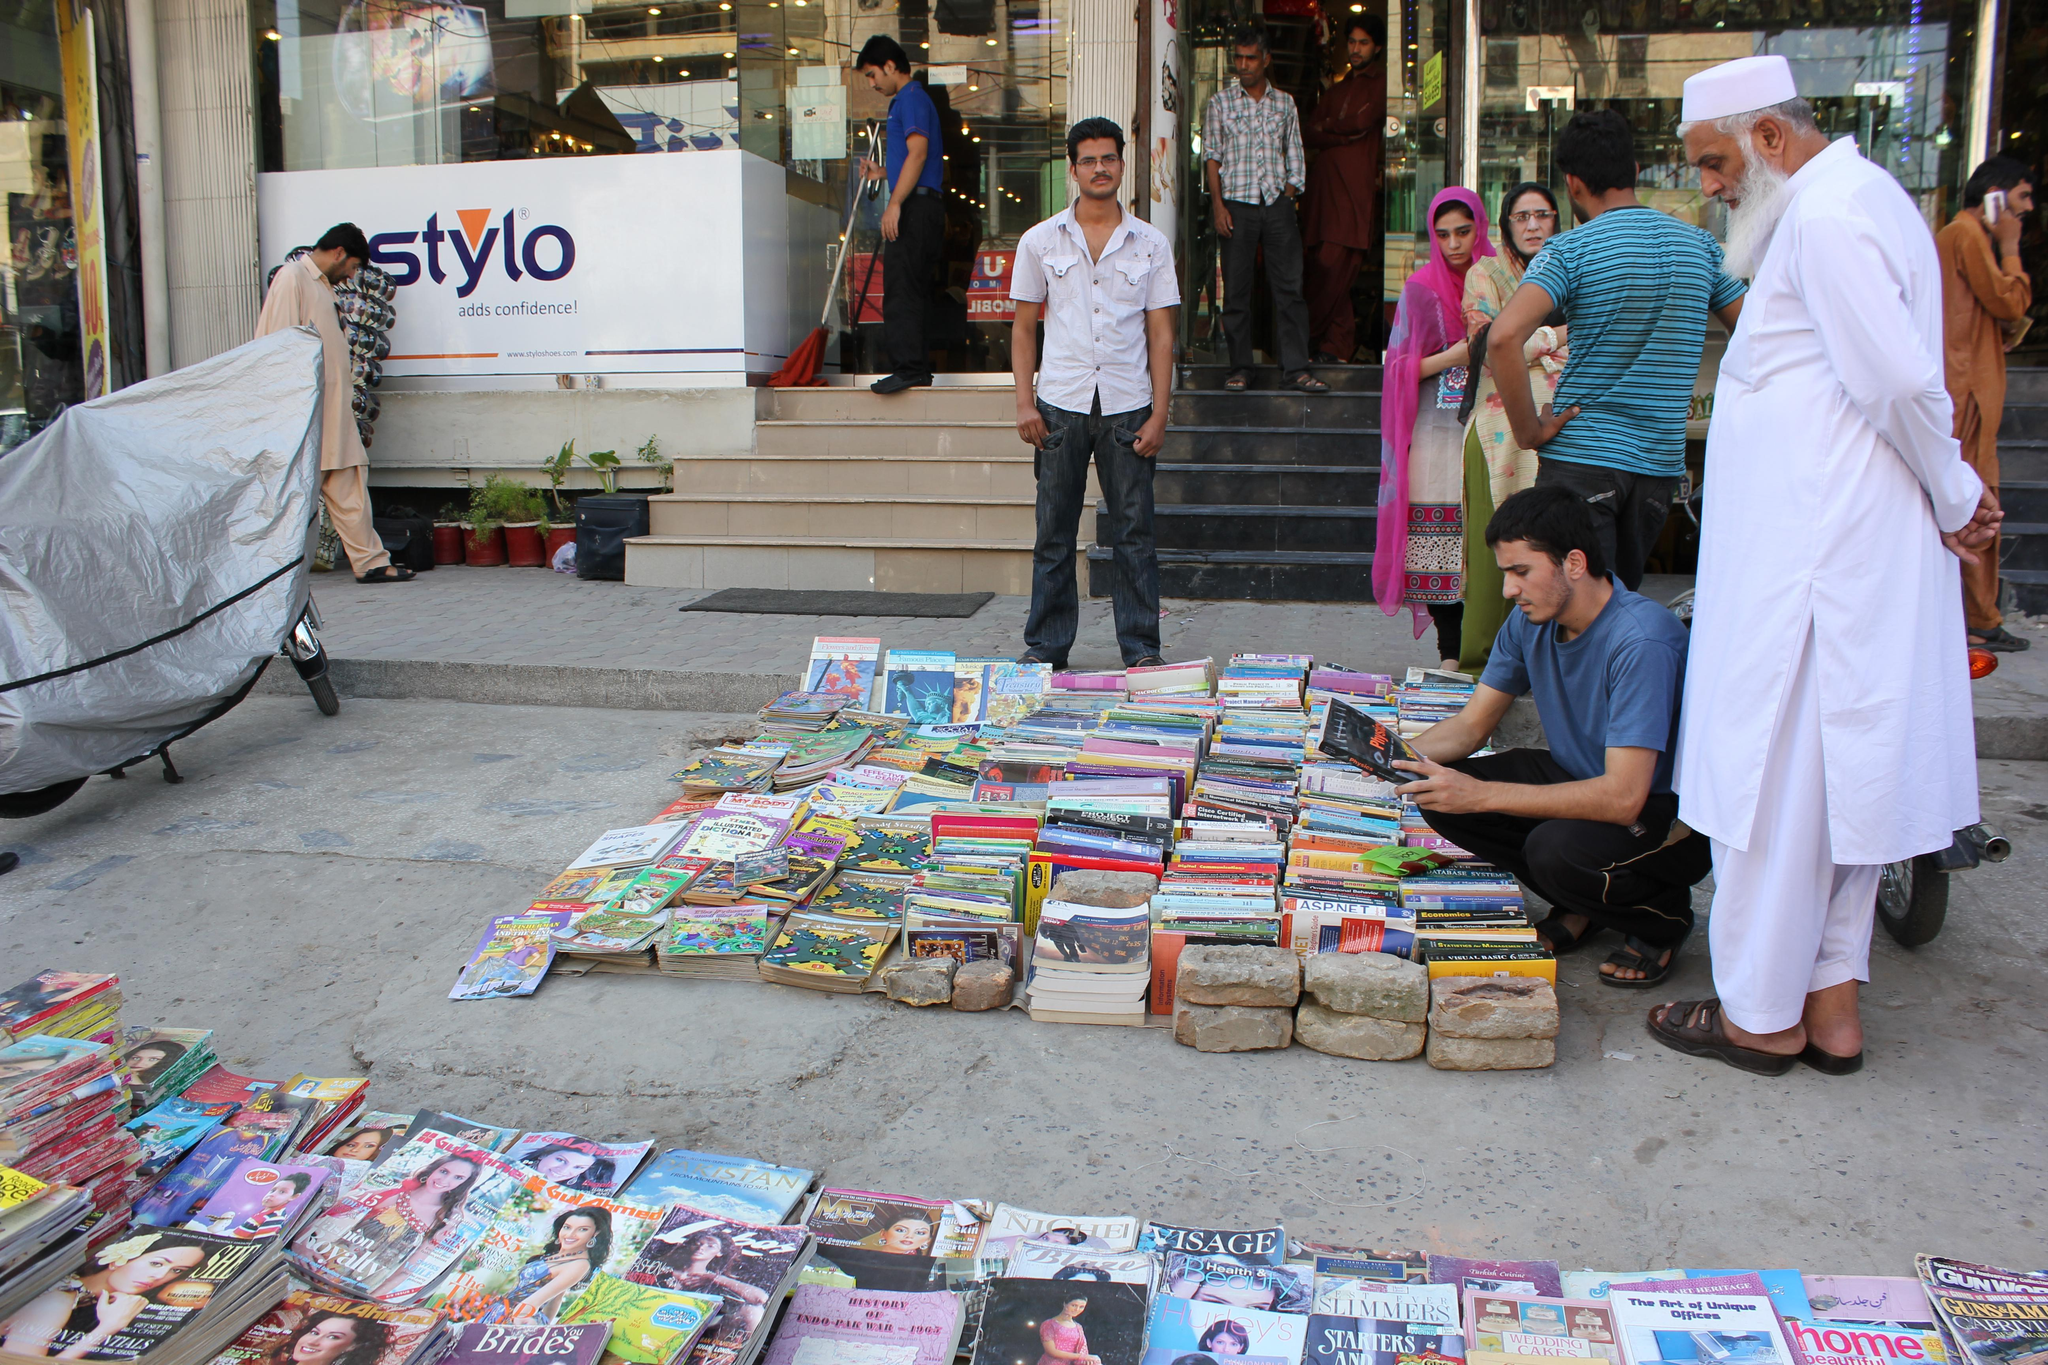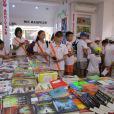The first image is the image on the left, the second image is the image on the right. For the images displayed, is the sentence "One image shows a man in a light colored button up shirt sitting outside the store front next to piles of books." factually correct? Answer yes or no. No. The first image is the image on the left, the second image is the image on the right. For the images displayed, is the sentence "There are no more than 3 people at the book store." factually correct? Answer yes or no. No. 